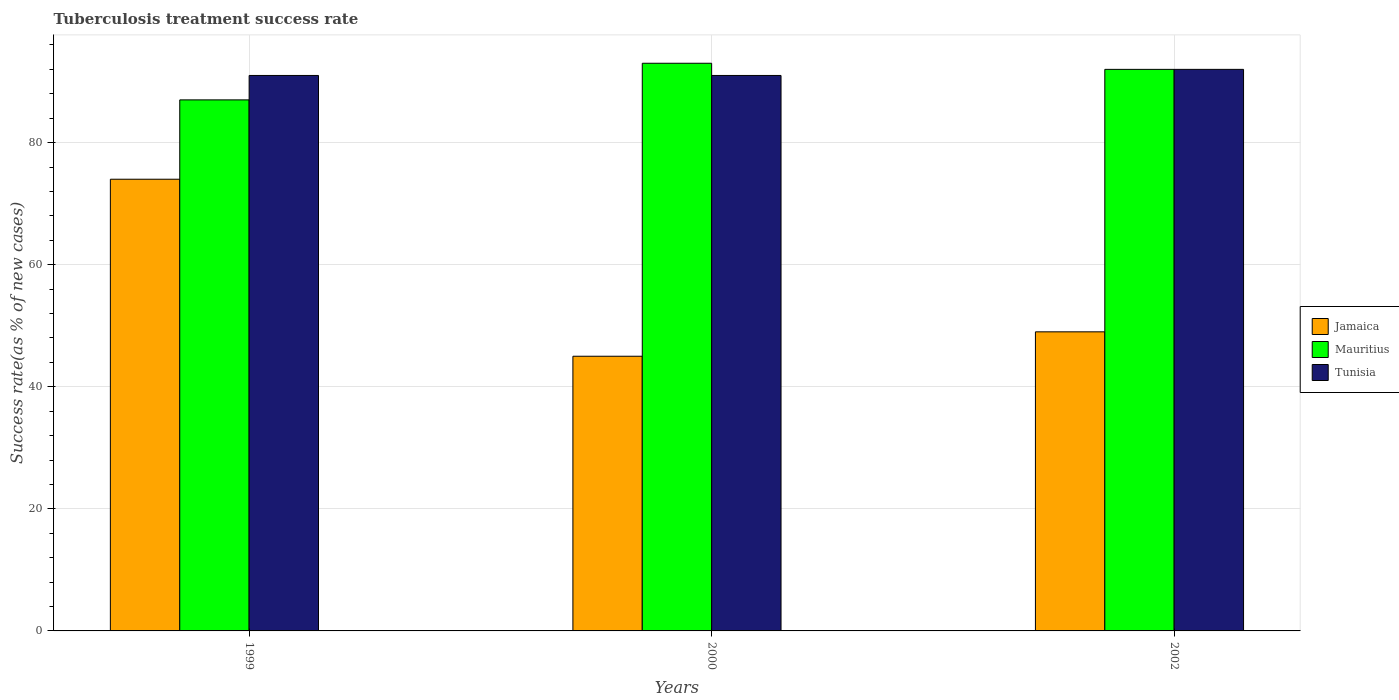How many groups of bars are there?
Give a very brief answer. 3. Are the number of bars on each tick of the X-axis equal?
Your answer should be very brief. Yes. Across all years, what is the maximum tuberculosis treatment success rate in Mauritius?
Provide a short and direct response. 93. Across all years, what is the minimum tuberculosis treatment success rate in Tunisia?
Your response must be concise. 91. In which year was the tuberculosis treatment success rate in Jamaica minimum?
Ensure brevity in your answer.  2000. What is the total tuberculosis treatment success rate in Tunisia in the graph?
Make the answer very short. 274. What is the difference between the tuberculosis treatment success rate in Tunisia in 2000 and the tuberculosis treatment success rate in Jamaica in 2002?
Ensure brevity in your answer.  42. What is the average tuberculosis treatment success rate in Tunisia per year?
Your response must be concise. 91.33. In the year 2002, what is the difference between the tuberculosis treatment success rate in Jamaica and tuberculosis treatment success rate in Mauritius?
Provide a short and direct response. -43. What is the ratio of the tuberculosis treatment success rate in Jamaica in 1999 to that in 2002?
Provide a short and direct response. 1.51. What is the difference between the highest and the second highest tuberculosis treatment success rate in Jamaica?
Give a very brief answer. 25. What is the difference between the highest and the lowest tuberculosis treatment success rate in Mauritius?
Give a very brief answer. 6. Is the sum of the tuberculosis treatment success rate in Mauritius in 1999 and 2002 greater than the maximum tuberculosis treatment success rate in Jamaica across all years?
Your answer should be very brief. Yes. What does the 2nd bar from the left in 1999 represents?
Provide a succinct answer. Mauritius. What does the 1st bar from the right in 2002 represents?
Provide a succinct answer. Tunisia. Is it the case that in every year, the sum of the tuberculosis treatment success rate in Mauritius and tuberculosis treatment success rate in Jamaica is greater than the tuberculosis treatment success rate in Tunisia?
Provide a short and direct response. Yes. How many years are there in the graph?
Offer a very short reply. 3. What is the difference between two consecutive major ticks on the Y-axis?
Offer a very short reply. 20. Are the values on the major ticks of Y-axis written in scientific E-notation?
Keep it short and to the point. No. Does the graph contain any zero values?
Provide a short and direct response. No. Where does the legend appear in the graph?
Make the answer very short. Center right. How many legend labels are there?
Offer a terse response. 3. How are the legend labels stacked?
Your response must be concise. Vertical. What is the title of the graph?
Offer a terse response. Tuberculosis treatment success rate. What is the label or title of the Y-axis?
Provide a succinct answer. Success rate(as % of new cases). What is the Success rate(as % of new cases) in Tunisia in 1999?
Your answer should be very brief. 91. What is the Success rate(as % of new cases) of Jamaica in 2000?
Keep it short and to the point. 45. What is the Success rate(as % of new cases) of Mauritius in 2000?
Provide a short and direct response. 93. What is the Success rate(as % of new cases) in Tunisia in 2000?
Make the answer very short. 91. What is the Success rate(as % of new cases) in Jamaica in 2002?
Give a very brief answer. 49. What is the Success rate(as % of new cases) in Mauritius in 2002?
Your answer should be very brief. 92. What is the Success rate(as % of new cases) of Tunisia in 2002?
Give a very brief answer. 92. Across all years, what is the maximum Success rate(as % of new cases) in Mauritius?
Ensure brevity in your answer.  93. Across all years, what is the maximum Success rate(as % of new cases) of Tunisia?
Give a very brief answer. 92. Across all years, what is the minimum Success rate(as % of new cases) in Mauritius?
Your answer should be very brief. 87. Across all years, what is the minimum Success rate(as % of new cases) of Tunisia?
Offer a very short reply. 91. What is the total Success rate(as % of new cases) in Jamaica in the graph?
Your answer should be compact. 168. What is the total Success rate(as % of new cases) in Mauritius in the graph?
Offer a very short reply. 272. What is the total Success rate(as % of new cases) in Tunisia in the graph?
Provide a succinct answer. 274. What is the difference between the Success rate(as % of new cases) in Jamaica in 1999 and that in 2000?
Your response must be concise. 29. What is the difference between the Success rate(as % of new cases) in Tunisia in 1999 and that in 2000?
Provide a succinct answer. 0. What is the difference between the Success rate(as % of new cases) of Tunisia in 1999 and that in 2002?
Give a very brief answer. -1. What is the difference between the Success rate(as % of new cases) of Jamaica in 2000 and that in 2002?
Your response must be concise. -4. What is the difference between the Success rate(as % of new cases) of Tunisia in 2000 and that in 2002?
Your answer should be compact. -1. What is the difference between the Success rate(as % of new cases) of Mauritius in 1999 and the Success rate(as % of new cases) of Tunisia in 2000?
Make the answer very short. -4. What is the difference between the Success rate(as % of new cases) of Mauritius in 1999 and the Success rate(as % of new cases) of Tunisia in 2002?
Your response must be concise. -5. What is the difference between the Success rate(as % of new cases) in Jamaica in 2000 and the Success rate(as % of new cases) in Mauritius in 2002?
Keep it short and to the point. -47. What is the difference between the Success rate(as % of new cases) in Jamaica in 2000 and the Success rate(as % of new cases) in Tunisia in 2002?
Ensure brevity in your answer.  -47. What is the average Success rate(as % of new cases) of Jamaica per year?
Your answer should be very brief. 56. What is the average Success rate(as % of new cases) in Mauritius per year?
Keep it short and to the point. 90.67. What is the average Success rate(as % of new cases) in Tunisia per year?
Your response must be concise. 91.33. In the year 1999, what is the difference between the Success rate(as % of new cases) in Jamaica and Success rate(as % of new cases) in Tunisia?
Your answer should be compact. -17. In the year 2000, what is the difference between the Success rate(as % of new cases) of Jamaica and Success rate(as % of new cases) of Mauritius?
Make the answer very short. -48. In the year 2000, what is the difference between the Success rate(as % of new cases) in Jamaica and Success rate(as % of new cases) in Tunisia?
Your answer should be very brief. -46. In the year 2000, what is the difference between the Success rate(as % of new cases) in Mauritius and Success rate(as % of new cases) in Tunisia?
Provide a short and direct response. 2. In the year 2002, what is the difference between the Success rate(as % of new cases) of Jamaica and Success rate(as % of new cases) of Mauritius?
Offer a terse response. -43. In the year 2002, what is the difference between the Success rate(as % of new cases) of Jamaica and Success rate(as % of new cases) of Tunisia?
Provide a short and direct response. -43. What is the ratio of the Success rate(as % of new cases) of Jamaica in 1999 to that in 2000?
Provide a short and direct response. 1.64. What is the ratio of the Success rate(as % of new cases) in Mauritius in 1999 to that in 2000?
Keep it short and to the point. 0.94. What is the ratio of the Success rate(as % of new cases) in Tunisia in 1999 to that in 2000?
Provide a succinct answer. 1. What is the ratio of the Success rate(as % of new cases) of Jamaica in 1999 to that in 2002?
Give a very brief answer. 1.51. What is the ratio of the Success rate(as % of new cases) of Mauritius in 1999 to that in 2002?
Offer a very short reply. 0.95. What is the ratio of the Success rate(as % of new cases) of Tunisia in 1999 to that in 2002?
Provide a succinct answer. 0.99. What is the ratio of the Success rate(as % of new cases) of Jamaica in 2000 to that in 2002?
Ensure brevity in your answer.  0.92. What is the ratio of the Success rate(as % of new cases) of Mauritius in 2000 to that in 2002?
Your answer should be very brief. 1.01. What is the difference between the highest and the second highest Success rate(as % of new cases) of Jamaica?
Provide a short and direct response. 25. What is the difference between the highest and the second highest Success rate(as % of new cases) of Mauritius?
Your response must be concise. 1. What is the difference between the highest and the second highest Success rate(as % of new cases) of Tunisia?
Your answer should be very brief. 1. What is the difference between the highest and the lowest Success rate(as % of new cases) in Tunisia?
Offer a terse response. 1. 